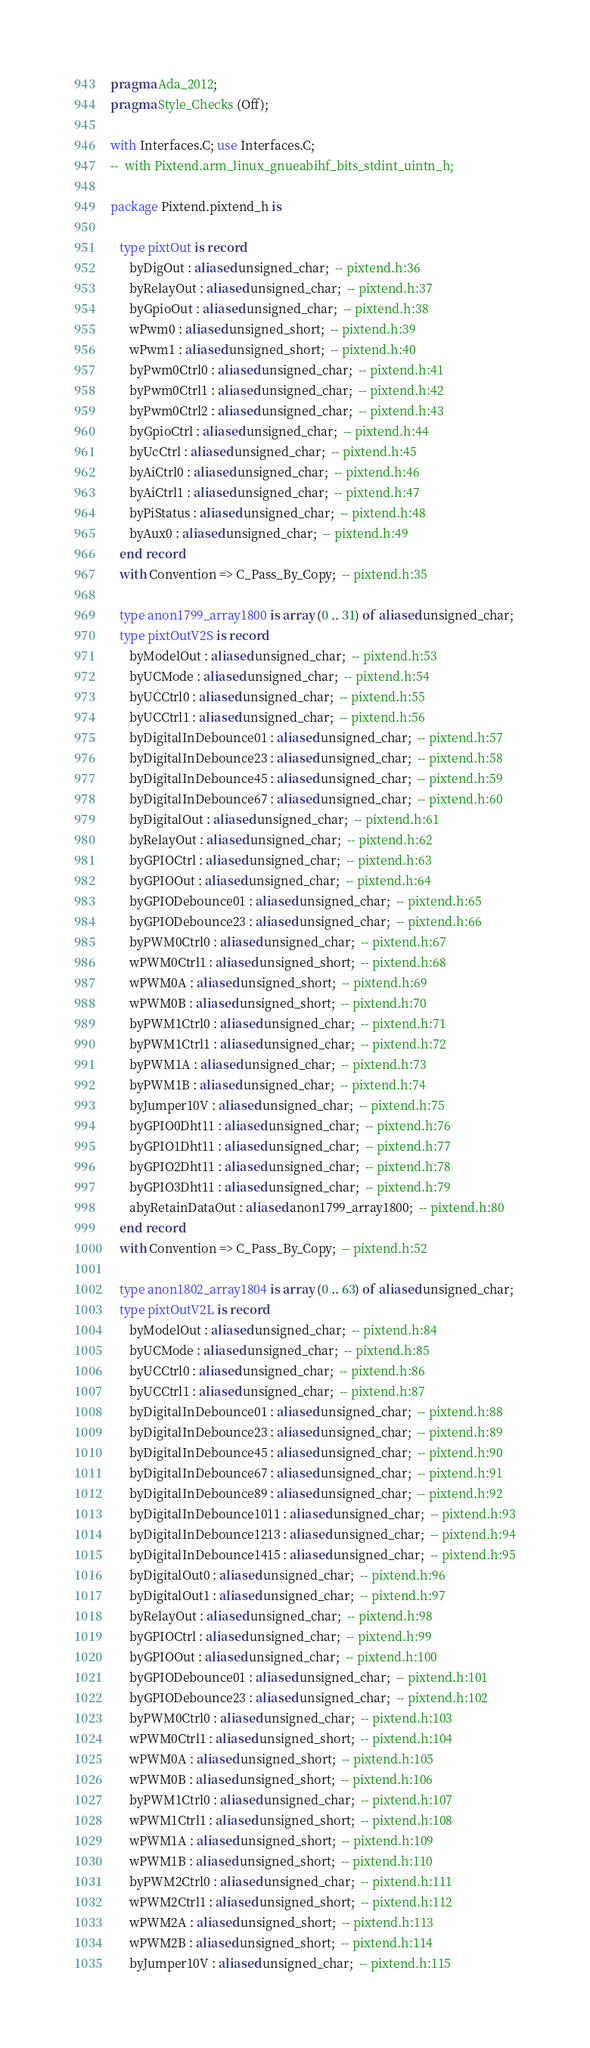<code> <loc_0><loc_0><loc_500><loc_500><_Ada_>pragma Ada_2012;
pragma Style_Checks (Off);

with Interfaces.C; use Interfaces.C;
--  with Pixtend.arm_linux_gnueabihf_bits_stdint_uintn_h;

package Pixtend.pixtend_h is

   type pixtOut is record
      byDigOut : aliased unsigned_char;  -- pixtend.h:36
      byRelayOut : aliased unsigned_char;  -- pixtend.h:37
      byGpioOut : aliased unsigned_char;  -- pixtend.h:38
      wPwm0 : aliased unsigned_short;  -- pixtend.h:39
      wPwm1 : aliased unsigned_short;  -- pixtend.h:40
      byPwm0Ctrl0 : aliased unsigned_char;  -- pixtend.h:41
      byPwm0Ctrl1 : aliased unsigned_char;  -- pixtend.h:42
      byPwm0Ctrl2 : aliased unsigned_char;  -- pixtend.h:43
      byGpioCtrl : aliased unsigned_char;  -- pixtend.h:44
      byUcCtrl : aliased unsigned_char;  -- pixtend.h:45
      byAiCtrl0 : aliased unsigned_char;  -- pixtend.h:46
      byAiCtrl1 : aliased unsigned_char;  -- pixtend.h:47
      byPiStatus : aliased unsigned_char;  -- pixtend.h:48
      byAux0 : aliased unsigned_char;  -- pixtend.h:49
   end record
   with Convention => C_Pass_By_Copy;  -- pixtend.h:35

   type anon1799_array1800 is array (0 .. 31) of aliased unsigned_char;
   type pixtOutV2S is record
      byModelOut : aliased unsigned_char;  -- pixtend.h:53
      byUCMode : aliased unsigned_char;  -- pixtend.h:54
      byUCCtrl0 : aliased unsigned_char;  -- pixtend.h:55
      byUCCtrl1 : aliased unsigned_char;  -- pixtend.h:56
      byDigitalInDebounce01 : aliased unsigned_char;  -- pixtend.h:57
      byDigitalInDebounce23 : aliased unsigned_char;  -- pixtend.h:58
      byDigitalInDebounce45 : aliased unsigned_char;  -- pixtend.h:59
      byDigitalInDebounce67 : aliased unsigned_char;  -- pixtend.h:60
      byDigitalOut : aliased unsigned_char;  -- pixtend.h:61
      byRelayOut : aliased unsigned_char;  -- pixtend.h:62
      byGPIOCtrl : aliased unsigned_char;  -- pixtend.h:63
      byGPIOOut : aliased unsigned_char;  -- pixtend.h:64
      byGPIODebounce01 : aliased unsigned_char;  -- pixtend.h:65
      byGPIODebounce23 : aliased unsigned_char;  -- pixtend.h:66
      byPWM0Ctrl0 : aliased unsigned_char;  -- pixtend.h:67
      wPWM0Ctrl1 : aliased unsigned_short;  -- pixtend.h:68
      wPWM0A : aliased unsigned_short;  -- pixtend.h:69
      wPWM0B : aliased unsigned_short;  -- pixtend.h:70
      byPWM1Ctrl0 : aliased unsigned_char;  -- pixtend.h:71
      byPWM1Ctrl1 : aliased unsigned_char;  -- pixtend.h:72
      byPWM1A : aliased unsigned_char;  -- pixtend.h:73
      byPWM1B : aliased unsigned_char;  -- pixtend.h:74
      byJumper10V : aliased unsigned_char;  -- pixtend.h:75
      byGPIO0Dht11 : aliased unsigned_char;  -- pixtend.h:76
      byGPIO1Dht11 : aliased unsigned_char;  -- pixtend.h:77
      byGPIO2Dht11 : aliased unsigned_char;  -- pixtend.h:78
      byGPIO3Dht11 : aliased unsigned_char;  -- pixtend.h:79
      abyRetainDataOut : aliased anon1799_array1800;  -- pixtend.h:80
   end record
   with Convention => C_Pass_By_Copy;  -- pixtend.h:52

   type anon1802_array1804 is array (0 .. 63) of aliased unsigned_char;
   type pixtOutV2L is record
      byModelOut : aliased unsigned_char;  -- pixtend.h:84
      byUCMode : aliased unsigned_char;  -- pixtend.h:85
      byUCCtrl0 : aliased unsigned_char;  -- pixtend.h:86
      byUCCtrl1 : aliased unsigned_char;  -- pixtend.h:87
      byDigitalInDebounce01 : aliased unsigned_char;  -- pixtend.h:88
      byDigitalInDebounce23 : aliased unsigned_char;  -- pixtend.h:89
      byDigitalInDebounce45 : aliased unsigned_char;  -- pixtend.h:90
      byDigitalInDebounce67 : aliased unsigned_char;  -- pixtend.h:91
      byDigitalInDebounce89 : aliased unsigned_char;  -- pixtend.h:92
      byDigitalInDebounce1011 : aliased unsigned_char;  -- pixtend.h:93
      byDigitalInDebounce1213 : aliased unsigned_char;  -- pixtend.h:94
      byDigitalInDebounce1415 : aliased unsigned_char;  -- pixtend.h:95
      byDigitalOut0 : aliased unsigned_char;  -- pixtend.h:96
      byDigitalOut1 : aliased unsigned_char;  -- pixtend.h:97
      byRelayOut : aliased unsigned_char;  -- pixtend.h:98
      byGPIOCtrl : aliased unsigned_char;  -- pixtend.h:99
      byGPIOOut : aliased unsigned_char;  -- pixtend.h:100
      byGPIODebounce01 : aliased unsigned_char;  -- pixtend.h:101
      byGPIODebounce23 : aliased unsigned_char;  -- pixtend.h:102
      byPWM0Ctrl0 : aliased unsigned_char;  -- pixtend.h:103
      wPWM0Ctrl1 : aliased unsigned_short;  -- pixtend.h:104
      wPWM0A : aliased unsigned_short;  -- pixtend.h:105
      wPWM0B : aliased unsigned_short;  -- pixtend.h:106
      byPWM1Ctrl0 : aliased unsigned_char;  -- pixtend.h:107
      wPWM1Ctrl1 : aliased unsigned_short;  -- pixtend.h:108
      wPWM1A : aliased unsigned_short;  -- pixtend.h:109
      wPWM1B : aliased unsigned_short;  -- pixtend.h:110
      byPWM2Ctrl0 : aliased unsigned_char;  -- pixtend.h:111
      wPWM2Ctrl1 : aliased unsigned_short;  -- pixtend.h:112
      wPWM2A : aliased unsigned_short;  -- pixtend.h:113
      wPWM2B : aliased unsigned_short;  -- pixtend.h:114
      byJumper10V : aliased unsigned_char;  -- pixtend.h:115</code> 